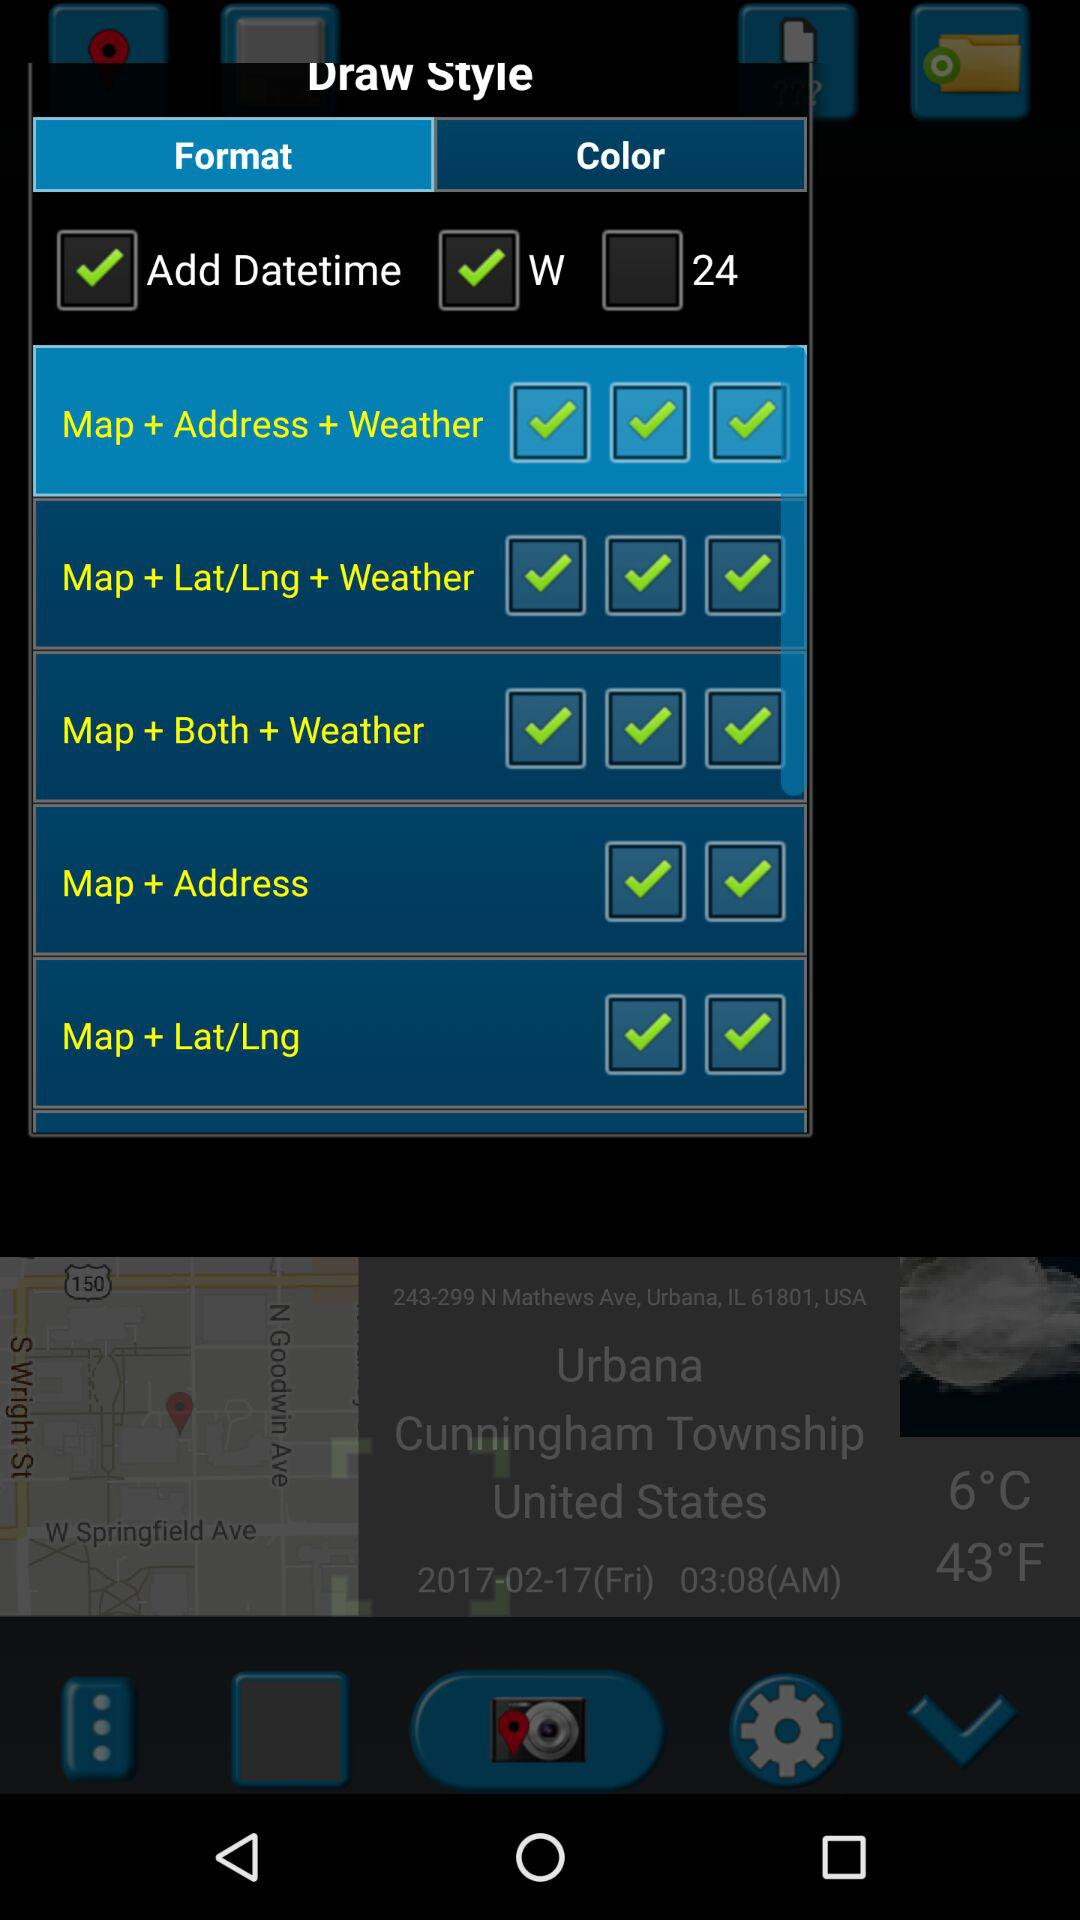Which tab has been selected? The selected tab is "Format". 